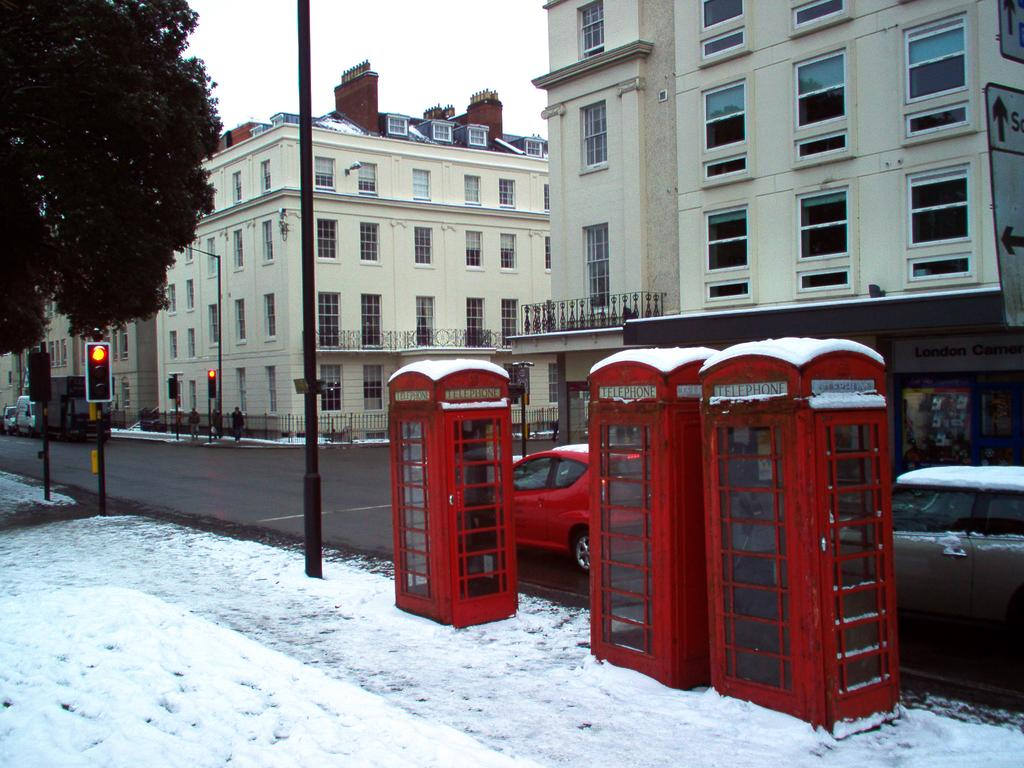What is the main feature of the image? There is a road in the image. What can be seen in the foreground of the image? There is snow in the foreground. What type of structures are present in the image? There are buildings in the image. What else can be seen on the road? There are vehicles in the image. Can you describe the tree placement in the image? There is a tree on the left side of the image. What else is visible in the image? There are signal poles in the image. What is visible above the scene? The sky is visible in the image. Where is the hospital located in the image? There is no hospital present in the image. What type of grass can be seen growing on the road? There is no grass visible on the road in the image. 